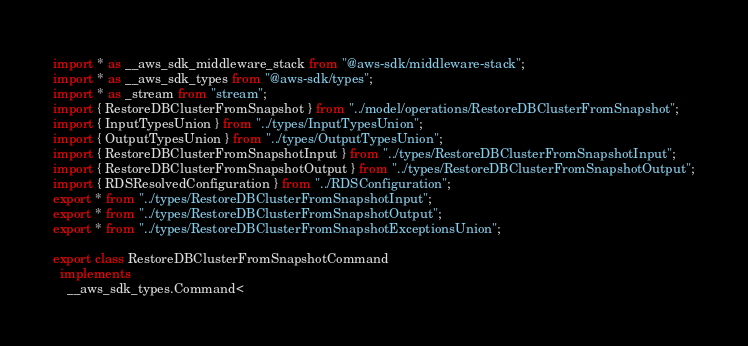Convert code to text. <code><loc_0><loc_0><loc_500><loc_500><_TypeScript_>import * as __aws_sdk_middleware_stack from "@aws-sdk/middleware-stack";
import * as __aws_sdk_types from "@aws-sdk/types";
import * as _stream from "stream";
import { RestoreDBClusterFromSnapshot } from "../model/operations/RestoreDBClusterFromSnapshot";
import { InputTypesUnion } from "../types/InputTypesUnion";
import { OutputTypesUnion } from "../types/OutputTypesUnion";
import { RestoreDBClusterFromSnapshotInput } from "../types/RestoreDBClusterFromSnapshotInput";
import { RestoreDBClusterFromSnapshotOutput } from "../types/RestoreDBClusterFromSnapshotOutput";
import { RDSResolvedConfiguration } from "../RDSConfiguration";
export * from "../types/RestoreDBClusterFromSnapshotInput";
export * from "../types/RestoreDBClusterFromSnapshotOutput";
export * from "../types/RestoreDBClusterFromSnapshotExceptionsUnion";

export class RestoreDBClusterFromSnapshotCommand
  implements
    __aws_sdk_types.Command<</code> 